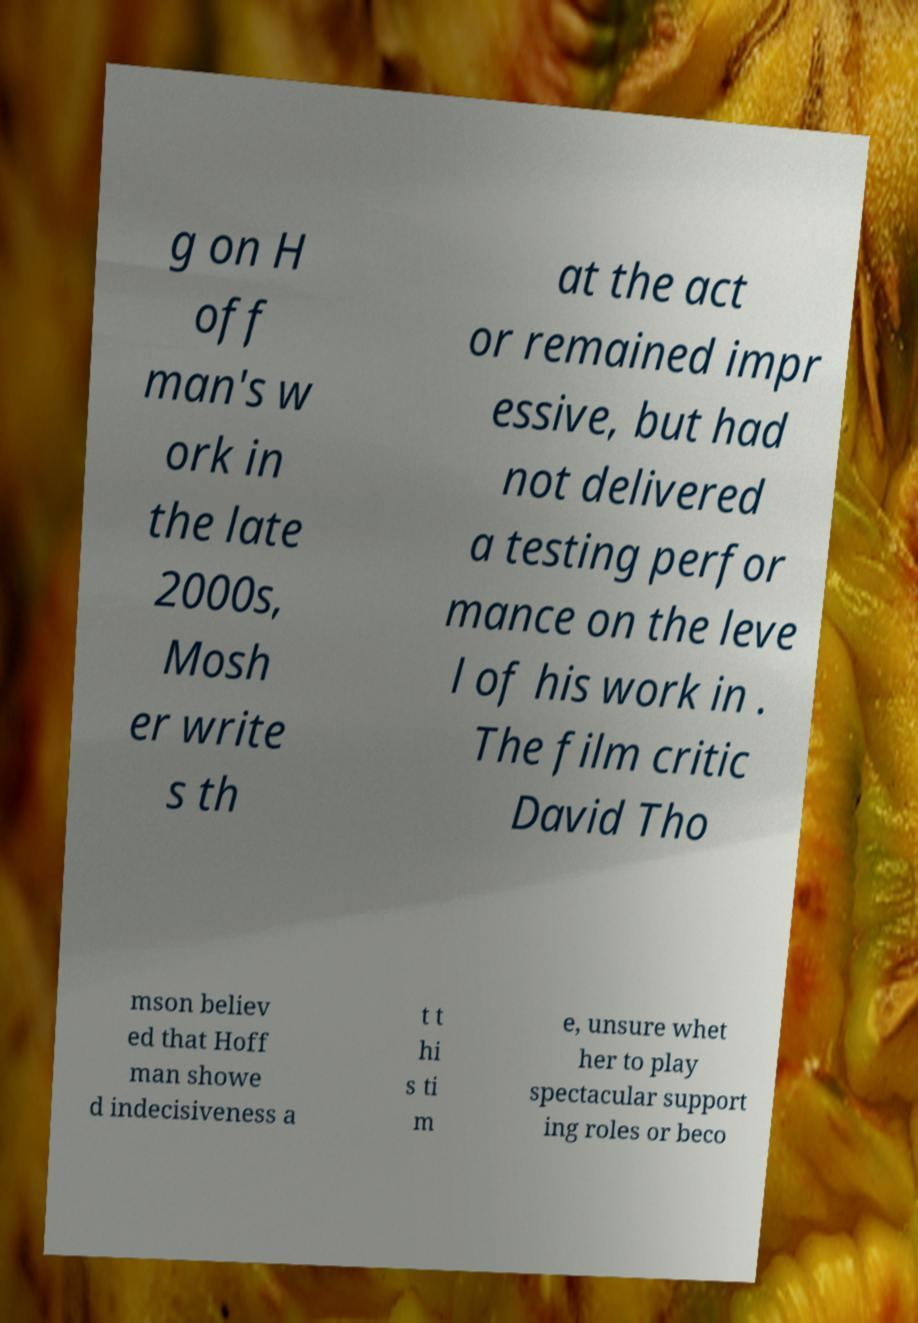Please identify and transcribe the text found in this image. g on H off man's w ork in the late 2000s, Mosh er write s th at the act or remained impr essive, but had not delivered a testing perfor mance on the leve l of his work in . The film critic David Tho mson believ ed that Hoff man showe d indecisiveness a t t hi s ti m e, unsure whet her to play spectacular support ing roles or beco 